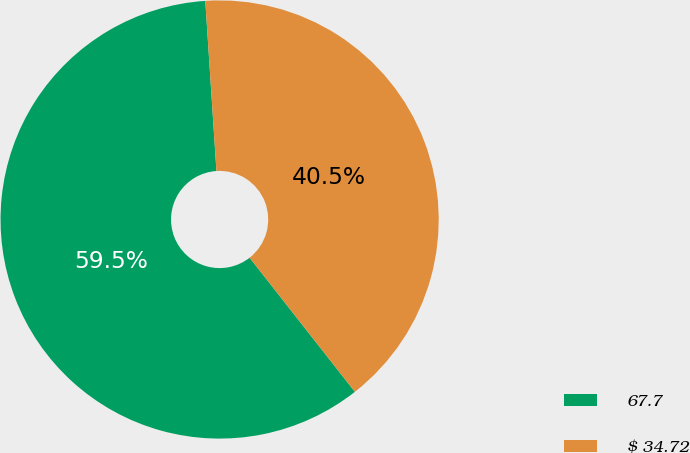<chart> <loc_0><loc_0><loc_500><loc_500><pie_chart><fcel>67.7<fcel>$ 34.72<nl><fcel>59.55%<fcel>40.45%<nl></chart> 